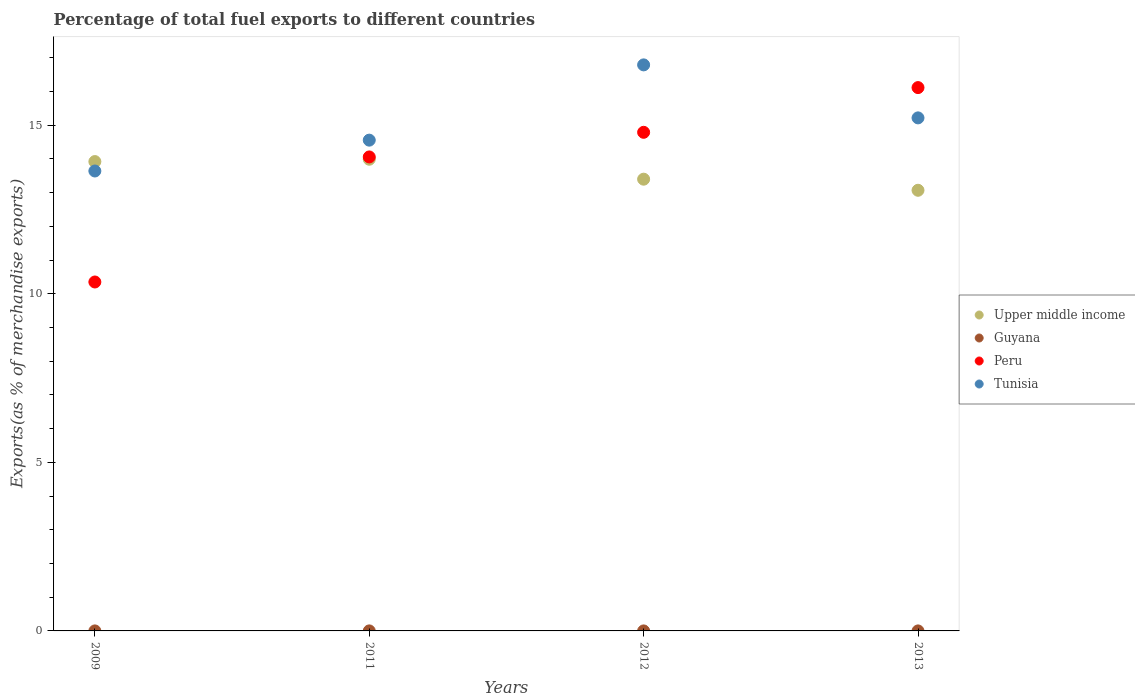How many different coloured dotlines are there?
Offer a terse response. 4. Is the number of dotlines equal to the number of legend labels?
Your answer should be compact. Yes. What is the percentage of exports to different countries in Peru in 2013?
Offer a terse response. 16.11. Across all years, what is the maximum percentage of exports to different countries in Tunisia?
Offer a terse response. 16.79. Across all years, what is the minimum percentage of exports to different countries in Upper middle income?
Your answer should be very brief. 13.07. In which year was the percentage of exports to different countries in Tunisia maximum?
Provide a short and direct response. 2012. What is the total percentage of exports to different countries in Guyana in the graph?
Provide a succinct answer. 0. What is the difference between the percentage of exports to different countries in Upper middle income in 2011 and that in 2012?
Your answer should be compact. 0.59. What is the difference between the percentage of exports to different countries in Tunisia in 2011 and the percentage of exports to different countries in Peru in 2009?
Keep it short and to the point. 4.21. What is the average percentage of exports to different countries in Upper middle income per year?
Give a very brief answer. 13.59. In the year 2009, what is the difference between the percentage of exports to different countries in Peru and percentage of exports to different countries in Tunisia?
Make the answer very short. -3.29. In how many years, is the percentage of exports to different countries in Tunisia greater than 7 %?
Your response must be concise. 4. What is the ratio of the percentage of exports to different countries in Guyana in 2012 to that in 2013?
Ensure brevity in your answer.  16.48. What is the difference between the highest and the second highest percentage of exports to different countries in Tunisia?
Offer a very short reply. 1.57. What is the difference between the highest and the lowest percentage of exports to different countries in Tunisia?
Keep it short and to the point. 3.15. In how many years, is the percentage of exports to different countries in Peru greater than the average percentage of exports to different countries in Peru taken over all years?
Offer a terse response. 3. Is the sum of the percentage of exports to different countries in Peru in 2009 and 2011 greater than the maximum percentage of exports to different countries in Upper middle income across all years?
Keep it short and to the point. Yes. Is it the case that in every year, the sum of the percentage of exports to different countries in Tunisia and percentage of exports to different countries in Upper middle income  is greater than the sum of percentage of exports to different countries in Peru and percentage of exports to different countries in Guyana?
Your response must be concise. No. Is it the case that in every year, the sum of the percentage of exports to different countries in Tunisia and percentage of exports to different countries in Guyana  is greater than the percentage of exports to different countries in Upper middle income?
Make the answer very short. No. Does the percentage of exports to different countries in Upper middle income monotonically increase over the years?
Provide a short and direct response. No. What is the difference between two consecutive major ticks on the Y-axis?
Offer a very short reply. 5. Does the graph contain any zero values?
Keep it short and to the point. No. Does the graph contain grids?
Give a very brief answer. No. Where does the legend appear in the graph?
Provide a short and direct response. Center right. How many legend labels are there?
Offer a terse response. 4. How are the legend labels stacked?
Offer a very short reply. Vertical. What is the title of the graph?
Give a very brief answer. Percentage of total fuel exports to different countries. Does "Cabo Verde" appear as one of the legend labels in the graph?
Offer a very short reply. No. What is the label or title of the X-axis?
Make the answer very short. Years. What is the label or title of the Y-axis?
Your answer should be compact. Exports(as % of merchandise exports). What is the Exports(as % of merchandise exports) in Upper middle income in 2009?
Provide a succinct answer. 13.92. What is the Exports(as % of merchandise exports) of Guyana in 2009?
Provide a short and direct response. 0. What is the Exports(as % of merchandise exports) in Peru in 2009?
Offer a terse response. 10.35. What is the Exports(as % of merchandise exports) of Tunisia in 2009?
Offer a terse response. 13.64. What is the Exports(as % of merchandise exports) in Upper middle income in 2011?
Offer a terse response. 13.99. What is the Exports(as % of merchandise exports) in Guyana in 2011?
Offer a terse response. 0. What is the Exports(as % of merchandise exports) of Peru in 2011?
Keep it short and to the point. 14.06. What is the Exports(as % of merchandise exports) in Tunisia in 2011?
Provide a succinct answer. 14.56. What is the Exports(as % of merchandise exports) in Upper middle income in 2012?
Offer a very short reply. 13.4. What is the Exports(as % of merchandise exports) of Guyana in 2012?
Your answer should be very brief. 8.26239513499483e-5. What is the Exports(as % of merchandise exports) in Peru in 2012?
Your answer should be very brief. 14.79. What is the Exports(as % of merchandise exports) of Tunisia in 2012?
Make the answer very short. 16.79. What is the Exports(as % of merchandise exports) of Upper middle income in 2013?
Make the answer very short. 13.07. What is the Exports(as % of merchandise exports) of Guyana in 2013?
Offer a very short reply. 5.01317432970329e-6. What is the Exports(as % of merchandise exports) of Peru in 2013?
Offer a terse response. 16.11. What is the Exports(as % of merchandise exports) of Tunisia in 2013?
Ensure brevity in your answer.  15.22. Across all years, what is the maximum Exports(as % of merchandise exports) in Upper middle income?
Provide a succinct answer. 13.99. Across all years, what is the maximum Exports(as % of merchandise exports) of Guyana?
Offer a very short reply. 0. Across all years, what is the maximum Exports(as % of merchandise exports) in Peru?
Your answer should be very brief. 16.11. Across all years, what is the maximum Exports(as % of merchandise exports) in Tunisia?
Your response must be concise. 16.79. Across all years, what is the minimum Exports(as % of merchandise exports) of Upper middle income?
Provide a succinct answer. 13.07. Across all years, what is the minimum Exports(as % of merchandise exports) in Guyana?
Provide a short and direct response. 5.01317432970329e-6. Across all years, what is the minimum Exports(as % of merchandise exports) of Peru?
Keep it short and to the point. 10.35. Across all years, what is the minimum Exports(as % of merchandise exports) in Tunisia?
Your answer should be compact. 13.64. What is the total Exports(as % of merchandise exports) of Upper middle income in the graph?
Make the answer very short. 54.38. What is the total Exports(as % of merchandise exports) in Guyana in the graph?
Offer a terse response. 0. What is the total Exports(as % of merchandise exports) of Peru in the graph?
Keep it short and to the point. 55.31. What is the total Exports(as % of merchandise exports) of Tunisia in the graph?
Provide a succinct answer. 60.2. What is the difference between the Exports(as % of merchandise exports) of Upper middle income in 2009 and that in 2011?
Provide a succinct answer. -0.07. What is the difference between the Exports(as % of merchandise exports) of Guyana in 2009 and that in 2011?
Make the answer very short. -0. What is the difference between the Exports(as % of merchandise exports) of Peru in 2009 and that in 2011?
Your answer should be very brief. -3.71. What is the difference between the Exports(as % of merchandise exports) in Tunisia in 2009 and that in 2011?
Your answer should be very brief. -0.92. What is the difference between the Exports(as % of merchandise exports) of Upper middle income in 2009 and that in 2012?
Offer a terse response. 0.52. What is the difference between the Exports(as % of merchandise exports) of Guyana in 2009 and that in 2012?
Make the answer very short. 0. What is the difference between the Exports(as % of merchandise exports) in Peru in 2009 and that in 2012?
Offer a terse response. -4.44. What is the difference between the Exports(as % of merchandise exports) in Tunisia in 2009 and that in 2012?
Offer a very short reply. -3.15. What is the difference between the Exports(as % of merchandise exports) in Upper middle income in 2009 and that in 2013?
Offer a terse response. 0.85. What is the difference between the Exports(as % of merchandise exports) in Peru in 2009 and that in 2013?
Provide a succinct answer. -5.77. What is the difference between the Exports(as % of merchandise exports) in Tunisia in 2009 and that in 2013?
Your answer should be compact. -1.58. What is the difference between the Exports(as % of merchandise exports) in Upper middle income in 2011 and that in 2012?
Make the answer very short. 0.59. What is the difference between the Exports(as % of merchandise exports) in Guyana in 2011 and that in 2012?
Offer a terse response. 0. What is the difference between the Exports(as % of merchandise exports) in Peru in 2011 and that in 2012?
Provide a succinct answer. -0.73. What is the difference between the Exports(as % of merchandise exports) of Tunisia in 2011 and that in 2012?
Offer a terse response. -2.23. What is the difference between the Exports(as % of merchandise exports) of Upper middle income in 2011 and that in 2013?
Offer a terse response. 0.92. What is the difference between the Exports(as % of merchandise exports) in Guyana in 2011 and that in 2013?
Provide a short and direct response. 0. What is the difference between the Exports(as % of merchandise exports) in Peru in 2011 and that in 2013?
Provide a succinct answer. -2.06. What is the difference between the Exports(as % of merchandise exports) in Tunisia in 2011 and that in 2013?
Offer a terse response. -0.66. What is the difference between the Exports(as % of merchandise exports) in Upper middle income in 2012 and that in 2013?
Offer a terse response. 0.33. What is the difference between the Exports(as % of merchandise exports) of Guyana in 2012 and that in 2013?
Offer a very short reply. 0. What is the difference between the Exports(as % of merchandise exports) in Peru in 2012 and that in 2013?
Provide a succinct answer. -1.33. What is the difference between the Exports(as % of merchandise exports) in Tunisia in 2012 and that in 2013?
Your answer should be compact. 1.57. What is the difference between the Exports(as % of merchandise exports) in Upper middle income in 2009 and the Exports(as % of merchandise exports) in Guyana in 2011?
Provide a succinct answer. 13.92. What is the difference between the Exports(as % of merchandise exports) in Upper middle income in 2009 and the Exports(as % of merchandise exports) in Peru in 2011?
Give a very brief answer. -0.14. What is the difference between the Exports(as % of merchandise exports) in Upper middle income in 2009 and the Exports(as % of merchandise exports) in Tunisia in 2011?
Your response must be concise. -0.64. What is the difference between the Exports(as % of merchandise exports) in Guyana in 2009 and the Exports(as % of merchandise exports) in Peru in 2011?
Keep it short and to the point. -14.06. What is the difference between the Exports(as % of merchandise exports) of Guyana in 2009 and the Exports(as % of merchandise exports) of Tunisia in 2011?
Provide a short and direct response. -14.56. What is the difference between the Exports(as % of merchandise exports) of Peru in 2009 and the Exports(as % of merchandise exports) of Tunisia in 2011?
Ensure brevity in your answer.  -4.21. What is the difference between the Exports(as % of merchandise exports) in Upper middle income in 2009 and the Exports(as % of merchandise exports) in Guyana in 2012?
Give a very brief answer. 13.92. What is the difference between the Exports(as % of merchandise exports) in Upper middle income in 2009 and the Exports(as % of merchandise exports) in Peru in 2012?
Offer a terse response. -0.87. What is the difference between the Exports(as % of merchandise exports) in Upper middle income in 2009 and the Exports(as % of merchandise exports) in Tunisia in 2012?
Offer a terse response. -2.87. What is the difference between the Exports(as % of merchandise exports) of Guyana in 2009 and the Exports(as % of merchandise exports) of Peru in 2012?
Offer a terse response. -14.79. What is the difference between the Exports(as % of merchandise exports) in Guyana in 2009 and the Exports(as % of merchandise exports) in Tunisia in 2012?
Provide a short and direct response. -16.79. What is the difference between the Exports(as % of merchandise exports) of Peru in 2009 and the Exports(as % of merchandise exports) of Tunisia in 2012?
Your answer should be compact. -6.44. What is the difference between the Exports(as % of merchandise exports) in Upper middle income in 2009 and the Exports(as % of merchandise exports) in Guyana in 2013?
Ensure brevity in your answer.  13.92. What is the difference between the Exports(as % of merchandise exports) of Upper middle income in 2009 and the Exports(as % of merchandise exports) of Peru in 2013?
Offer a very short reply. -2.19. What is the difference between the Exports(as % of merchandise exports) of Upper middle income in 2009 and the Exports(as % of merchandise exports) of Tunisia in 2013?
Offer a very short reply. -1.3. What is the difference between the Exports(as % of merchandise exports) in Guyana in 2009 and the Exports(as % of merchandise exports) in Peru in 2013?
Provide a short and direct response. -16.11. What is the difference between the Exports(as % of merchandise exports) in Guyana in 2009 and the Exports(as % of merchandise exports) in Tunisia in 2013?
Offer a very short reply. -15.22. What is the difference between the Exports(as % of merchandise exports) in Peru in 2009 and the Exports(as % of merchandise exports) in Tunisia in 2013?
Give a very brief answer. -4.87. What is the difference between the Exports(as % of merchandise exports) of Upper middle income in 2011 and the Exports(as % of merchandise exports) of Guyana in 2012?
Your answer should be very brief. 13.99. What is the difference between the Exports(as % of merchandise exports) of Upper middle income in 2011 and the Exports(as % of merchandise exports) of Peru in 2012?
Keep it short and to the point. -0.8. What is the difference between the Exports(as % of merchandise exports) in Upper middle income in 2011 and the Exports(as % of merchandise exports) in Tunisia in 2012?
Offer a terse response. -2.8. What is the difference between the Exports(as % of merchandise exports) of Guyana in 2011 and the Exports(as % of merchandise exports) of Peru in 2012?
Offer a terse response. -14.79. What is the difference between the Exports(as % of merchandise exports) of Guyana in 2011 and the Exports(as % of merchandise exports) of Tunisia in 2012?
Provide a short and direct response. -16.79. What is the difference between the Exports(as % of merchandise exports) of Peru in 2011 and the Exports(as % of merchandise exports) of Tunisia in 2012?
Your answer should be very brief. -2.73. What is the difference between the Exports(as % of merchandise exports) in Upper middle income in 2011 and the Exports(as % of merchandise exports) in Guyana in 2013?
Make the answer very short. 13.99. What is the difference between the Exports(as % of merchandise exports) of Upper middle income in 2011 and the Exports(as % of merchandise exports) of Peru in 2013?
Provide a succinct answer. -2.12. What is the difference between the Exports(as % of merchandise exports) in Upper middle income in 2011 and the Exports(as % of merchandise exports) in Tunisia in 2013?
Offer a very short reply. -1.23. What is the difference between the Exports(as % of merchandise exports) in Guyana in 2011 and the Exports(as % of merchandise exports) in Peru in 2013?
Make the answer very short. -16.11. What is the difference between the Exports(as % of merchandise exports) of Guyana in 2011 and the Exports(as % of merchandise exports) of Tunisia in 2013?
Ensure brevity in your answer.  -15.22. What is the difference between the Exports(as % of merchandise exports) in Peru in 2011 and the Exports(as % of merchandise exports) in Tunisia in 2013?
Give a very brief answer. -1.16. What is the difference between the Exports(as % of merchandise exports) of Upper middle income in 2012 and the Exports(as % of merchandise exports) of Guyana in 2013?
Ensure brevity in your answer.  13.4. What is the difference between the Exports(as % of merchandise exports) in Upper middle income in 2012 and the Exports(as % of merchandise exports) in Peru in 2013?
Offer a terse response. -2.72. What is the difference between the Exports(as % of merchandise exports) in Upper middle income in 2012 and the Exports(as % of merchandise exports) in Tunisia in 2013?
Offer a terse response. -1.82. What is the difference between the Exports(as % of merchandise exports) in Guyana in 2012 and the Exports(as % of merchandise exports) in Peru in 2013?
Make the answer very short. -16.11. What is the difference between the Exports(as % of merchandise exports) in Guyana in 2012 and the Exports(as % of merchandise exports) in Tunisia in 2013?
Make the answer very short. -15.22. What is the difference between the Exports(as % of merchandise exports) of Peru in 2012 and the Exports(as % of merchandise exports) of Tunisia in 2013?
Offer a very short reply. -0.43. What is the average Exports(as % of merchandise exports) of Upper middle income per year?
Offer a terse response. 13.59. What is the average Exports(as % of merchandise exports) in Guyana per year?
Your answer should be compact. 0. What is the average Exports(as % of merchandise exports) in Peru per year?
Your answer should be compact. 13.83. What is the average Exports(as % of merchandise exports) in Tunisia per year?
Ensure brevity in your answer.  15.05. In the year 2009, what is the difference between the Exports(as % of merchandise exports) of Upper middle income and Exports(as % of merchandise exports) of Guyana?
Your answer should be compact. 13.92. In the year 2009, what is the difference between the Exports(as % of merchandise exports) in Upper middle income and Exports(as % of merchandise exports) in Peru?
Provide a short and direct response. 3.57. In the year 2009, what is the difference between the Exports(as % of merchandise exports) in Upper middle income and Exports(as % of merchandise exports) in Tunisia?
Your response must be concise. 0.28. In the year 2009, what is the difference between the Exports(as % of merchandise exports) in Guyana and Exports(as % of merchandise exports) in Peru?
Your answer should be compact. -10.35. In the year 2009, what is the difference between the Exports(as % of merchandise exports) in Guyana and Exports(as % of merchandise exports) in Tunisia?
Provide a short and direct response. -13.64. In the year 2009, what is the difference between the Exports(as % of merchandise exports) of Peru and Exports(as % of merchandise exports) of Tunisia?
Ensure brevity in your answer.  -3.29. In the year 2011, what is the difference between the Exports(as % of merchandise exports) in Upper middle income and Exports(as % of merchandise exports) in Guyana?
Your answer should be compact. 13.99. In the year 2011, what is the difference between the Exports(as % of merchandise exports) in Upper middle income and Exports(as % of merchandise exports) in Peru?
Give a very brief answer. -0.07. In the year 2011, what is the difference between the Exports(as % of merchandise exports) of Upper middle income and Exports(as % of merchandise exports) of Tunisia?
Give a very brief answer. -0.57. In the year 2011, what is the difference between the Exports(as % of merchandise exports) in Guyana and Exports(as % of merchandise exports) in Peru?
Your answer should be compact. -14.06. In the year 2011, what is the difference between the Exports(as % of merchandise exports) in Guyana and Exports(as % of merchandise exports) in Tunisia?
Keep it short and to the point. -14.55. In the year 2011, what is the difference between the Exports(as % of merchandise exports) in Peru and Exports(as % of merchandise exports) in Tunisia?
Your answer should be very brief. -0.5. In the year 2012, what is the difference between the Exports(as % of merchandise exports) in Upper middle income and Exports(as % of merchandise exports) in Guyana?
Offer a very short reply. 13.4. In the year 2012, what is the difference between the Exports(as % of merchandise exports) in Upper middle income and Exports(as % of merchandise exports) in Peru?
Ensure brevity in your answer.  -1.39. In the year 2012, what is the difference between the Exports(as % of merchandise exports) of Upper middle income and Exports(as % of merchandise exports) of Tunisia?
Offer a terse response. -3.39. In the year 2012, what is the difference between the Exports(as % of merchandise exports) of Guyana and Exports(as % of merchandise exports) of Peru?
Make the answer very short. -14.79. In the year 2012, what is the difference between the Exports(as % of merchandise exports) of Guyana and Exports(as % of merchandise exports) of Tunisia?
Your answer should be compact. -16.79. In the year 2012, what is the difference between the Exports(as % of merchandise exports) in Peru and Exports(as % of merchandise exports) in Tunisia?
Give a very brief answer. -2. In the year 2013, what is the difference between the Exports(as % of merchandise exports) in Upper middle income and Exports(as % of merchandise exports) in Guyana?
Provide a succinct answer. 13.07. In the year 2013, what is the difference between the Exports(as % of merchandise exports) in Upper middle income and Exports(as % of merchandise exports) in Peru?
Your answer should be compact. -3.05. In the year 2013, what is the difference between the Exports(as % of merchandise exports) in Upper middle income and Exports(as % of merchandise exports) in Tunisia?
Offer a terse response. -2.15. In the year 2013, what is the difference between the Exports(as % of merchandise exports) of Guyana and Exports(as % of merchandise exports) of Peru?
Make the answer very short. -16.11. In the year 2013, what is the difference between the Exports(as % of merchandise exports) in Guyana and Exports(as % of merchandise exports) in Tunisia?
Your answer should be compact. -15.22. In the year 2013, what is the difference between the Exports(as % of merchandise exports) of Peru and Exports(as % of merchandise exports) of Tunisia?
Provide a short and direct response. 0.9. What is the ratio of the Exports(as % of merchandise exports) of Guyana in 2009 to that in 2011?
Keep it short and to the point. 0.32. What is the ratio of the Exports(as % of merchandise exports) of Peru in 2009 to that in 2011?
Provide a succinct answer. 0.74. What is the ratio of the Exports(as % of merchandise exports) in Tunisia in 2009 to that in 2011?
Offer a terse response. 0.94. What is the ratio of the Exports(as % of merchandise exports) in Upper middle income in 2009 to that in 2012?
Give a very brief answer. 1.04. What is the ratio of the Exports(as % of merchandise exports) in Guyana in 2009 to that in 2012?
Give a very brief answer. 3.34. What is the ratio of the Exports(as % of merchandise exports) of Peru in 2009 to that in 2012?
Offer a very short reply. 0.7. What is the ratio of the Exports(as % of merchandise exports) of Tunisia in 2009 to that in 2012?
Ensure brevity in your answer.  0.81. What is the ratio of the Exports(as % of merchandise exports) in Upper middle income in 2009 to that in 2013?
Keep it short and to the point. 1.07. What is the ratio of the Exports(as % of merchandise exports) in Guyana in 2009 to that in 2013?
Provide a succinct answer. 55.05. What is the ratio of the Exports(as % of merchandise exports) in Peru in 2009 to that in 2013?
Give a very brief answer. 0.64. What is the ratio of the Exports(as % of merchandise exports) in Tunisia in 2009 to that in 2013?
Give a very brief answer. 0.9. What is the ratio of the Exports(as % of merchandise exports) in Upper middle income in 2011 to that in 2012?
Provide a succinct answer. 1.04. What is the ratio of the Exports(as % of merchandise exports) in Guyana in 2011 to that in 2012?
Your answer should be very brief. 10.58. What is the ratio of the Exports(as % of merchandise exports) in Peru in 2011 to that in 2012?
Ensure brevity in your answer.  0.95. What is the ratio of the Exports(as % of merchandise exports) of Tunisia in 2011 to that in 2012?
Provide a short and direct response. 0.87. What is the ratio of the Exports(as % of merchandise exports) in Upper middle income in 2011 to that in 2013?
Your answer should be compact. 1.07. What is the ratio of the Exports(as % of merchandise exports) in Guyana in 2011 to that in 2013?
Keep it short and to the point. 174.44. What is the ratio of the Exports(as % of merchandise exports) in Peru in 2011 to that in 2013?
Ensure brevity in your answer.  0.87. What is the ratio of the Exports(as % of merchandise exports) in Tunisia in 2011 to that in 2013?
Provide a short and direct response. 0.96. What is the ratio of the Exports(as % of merchandise exports) in Upper middle income in 2012 to that in 2013?
Keep it short and to the point. 1.03. What is the ratio of the Exports(as % of merchandise exports) in Guyana in 2012 to that in 2013?
Provide a short and direct response. 16.48. What is the ratio of the Exports(as % of merchandise exports) of Peru in 2012 to that in 2013?
Provide a short and direct response. 0.92. What is the ratio of the Exports(as % of merchandise exports) in Tunisia in 2012 to that in 2013?
Ensure brevity in your answer.  1.1. What is the difference between the highest and the second highest Exports(as % of merchandise exports) in Upper middle income?
Your response must be concise. 0.07. What is the difference between the highest and the second highest Exports(as % of merchandise exports) of Guyana?
Make the answer very short. 0. What is the difference between the highest and the second highest Exports(as % of merchandise exports) of Peru?
Your response must be concise. 1.33. What is the difference between the highest and the second highest Exports(as % of merchandise exports) in Tunisia?
Your answer should be very brief. 1.57. What is the difference between the highest and the lowest Exports(as % of merchandise exports) in Upper middle income?
Your answer should be compact. 0.92. What is the difference between the highest and the lowest Exports(as % of merchandise exports) of Guyana?
Ensure brevity in your answer.  0. What is the difference between the highest and the lowest Exports(as % of merchandise exports) of Peru?
Give a very brief answer. 5.77. What is the difference between the highest and the lowest Exports(as % of merchandise exports) in Tunisia?
Your response must be concise. 3.15. 